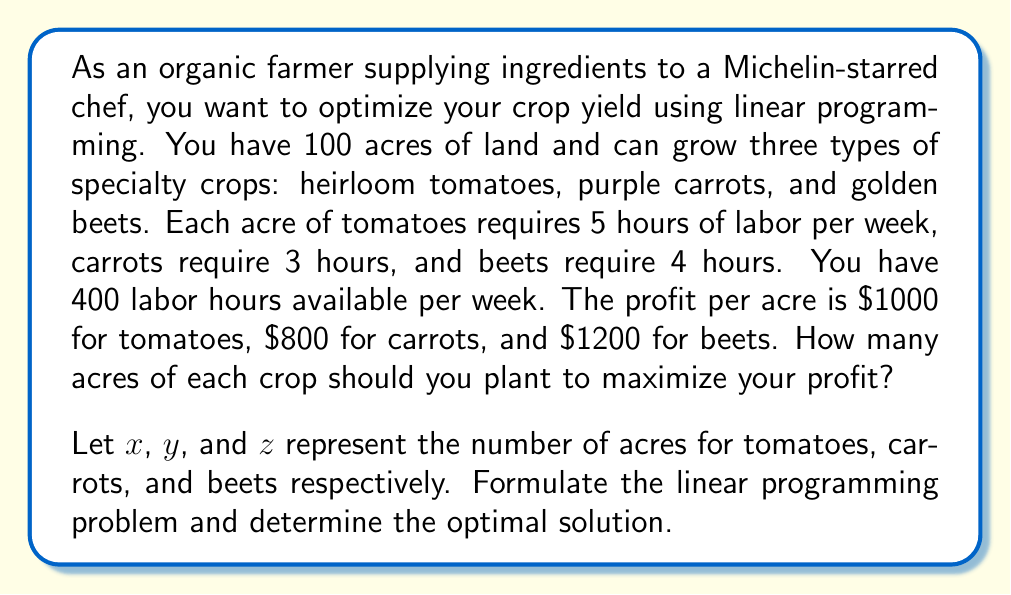Give your solution to this math problem. To solve this linear programming problem, we'll follow these steps:

1. Formulate the objective function:
   Maximize profit: $P = 1000x + 800y + 1200z$

2. Identify the constraints:
   a) Land constraint: $x + y + z \leq 100$
   b) Labor constraint: $5x + 3y + 4z \leq 400$
   c) Non-negativity: $x, y, z \geq 0$

3. Set up the linear programming problem:
   Maximize $P = 1000x + 800y + 1200z$
   Subject to:
   $$\begin{align}
   x + y + z &\leq 100 \\
   5x + 3y + 4z &\leq 400 \\
   x, y, z &\geq 0
   \end{align}$$

4. Solve using the simplex method or graphical method. In this case, we'll use the graphical method since we have only two effective constraints.

5. Plot the constraints:
   [asy]
   import graph;
   size(200,200);
   
   real f1(real x) {return 100-x;}
   real f2(real x) {return (400-5x)/3;}
   
   draw(graph(f1,0,100),blue);
   draw(graph(f2,0,80),red);
   draw((0,0)--(100,0)--(100,100)--(0,100)--cycle);
   
   label("Land constraint", (50,50), E);
   label("Labor constraint", (30,90), E);
   
   dot((0,100));
   dot((80,0));
   dot((60,40));
   
   label("(0,100)", (0,100), W);
   label("(80,0)", (80,0), S);
   label("(60,40)", (60,40), SE);
   [/asy]

6. Identify the feasible region and its corners:
   (0,0), (0,100), (60,40), (80,0)

7. Evaluate the objective function at each corner:
   $P(0,0) = 0$
   $P(0,100) = 80,000$
   $P(60,40) = 92,000$
   $P(80,0) = 80,000$

8. The maximum profit occurs at (60,40), which corresponds to 60 acres of tomatoes and 40 acres of carrots.

Therefore, the optimal solution is to plant 60 acres of tomatoes and 40 acres of carrots, with no golden beets.
Answer: 60 acres of tomatoes, 40 acres of carrots, 0 acres of beets 